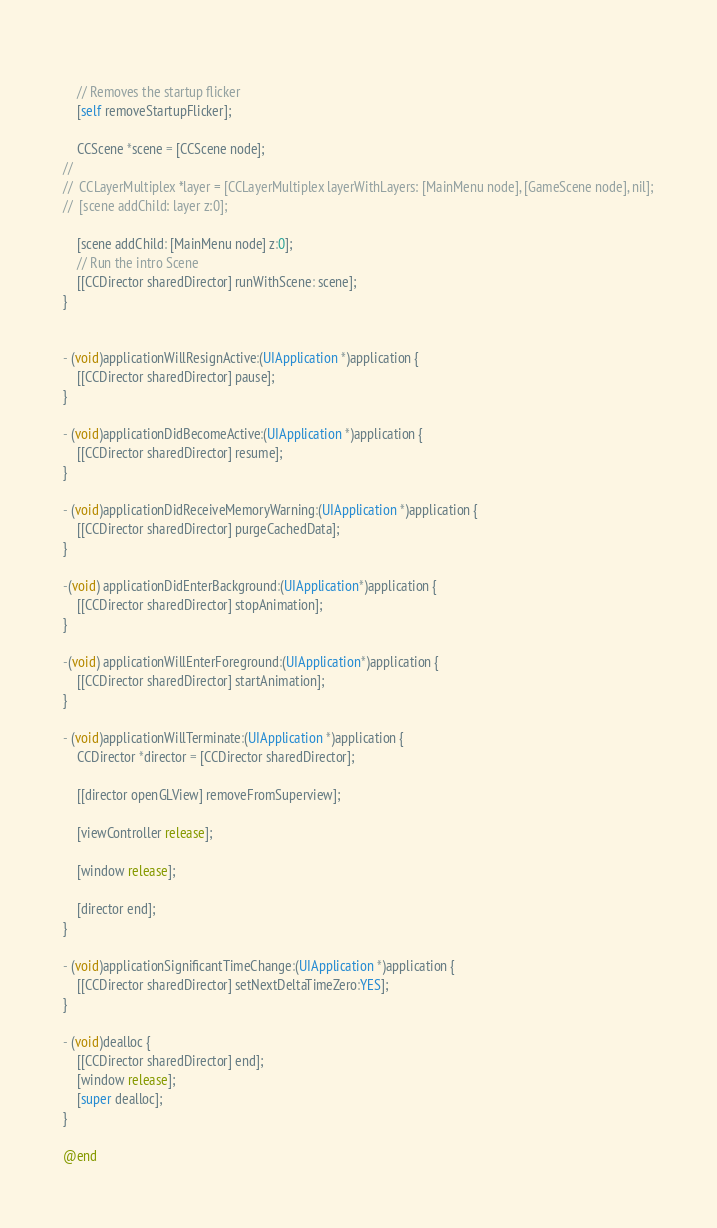<code> <loc_0><loc_0><loc_500><loc_500><_ObjectiveC_>	
	// Removes the startup flicker
	[self removeStartupFlicker];
    
    CCScene *scene = [CCScene node];
//    
//	CCLayerMultiplex *layer = [CCLayerMultiplex layerWithLayers: [MainMenu node], [GameScene node], nil];
//	[scene addChild: layer z:0];

    [scene addChild: [MainMenu node] z:0];
	// Run the intro Scene
	[[CCDirector sharedDirector] runWithScene: scene];
}


- (void)applicationWillResignActive:(UIApplication *)application {
	[[CCDirector sharedDirector] pause];
}

- (void)applicationDidBecomeActive:(UIApplication *)application {
	[[CCDirector sharedDirector] resume];
}

- (void)applicationDidReceiveMemoryWarning:(UIApplication *)application {
	[[CCDirector sharedDirector] purgeCachedData];
}

-(void) applicationDidEnterBackground:(UIApplication*)application {
	[[CCDirector sharedDirector] stopAnimation];
}

-(void) applicationWillEnterForeground:(UIApplication*)application {
	[[CCDirector sharedDirector] startAnimation];
}

- (void)applicationWillTerminate:(UIApplication *)application {
	CCDirector *director = [CCDirector sharedDirector];
	
	[[director openGLView] removeFromSuperview];
	
	[viewController release];
	
	[window release];
	
	[director end];	
}

- (void)applicationSignificantTimeChange:(UIApplication *)application {
	[[CCDirector sharedDirector] setNextDeltaTimeZero:YES];
}

- (void)dealloc {
	[[CCDirector sharedDirector] end];
	[window release];
	[super dealloc];
}

@end
</code> 